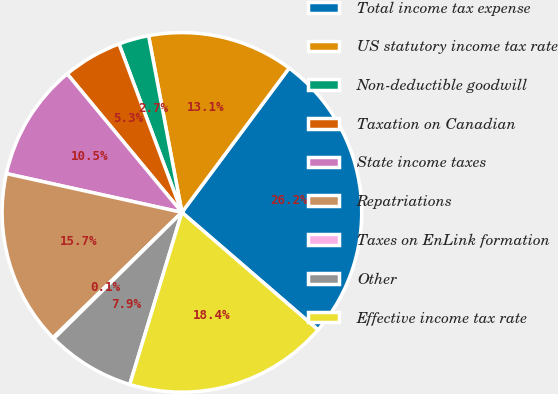Convert chart to OTSL. <chart><loc_0><loc_0><loc_500><loc_500><pie_chart><fcel>Total income tax expense<fcel>US statutory income tax rate<fcel>Non-deductible goodwill<fcel>Taxation on Canadian<fcel>State income taxes<fcel>Repatriations<fcel>Taxes on EnLink formation<fcel>Other<fcel>Effective income tax rate<nl><fcel>26.16%<fcel>13.14%<fcel>2.72%<fcel>5.32%<fcel>10.53%<fcel>15.74%<fcel>0.11%<fcel>7.93%<fcel>18.35%<nl></chart> 